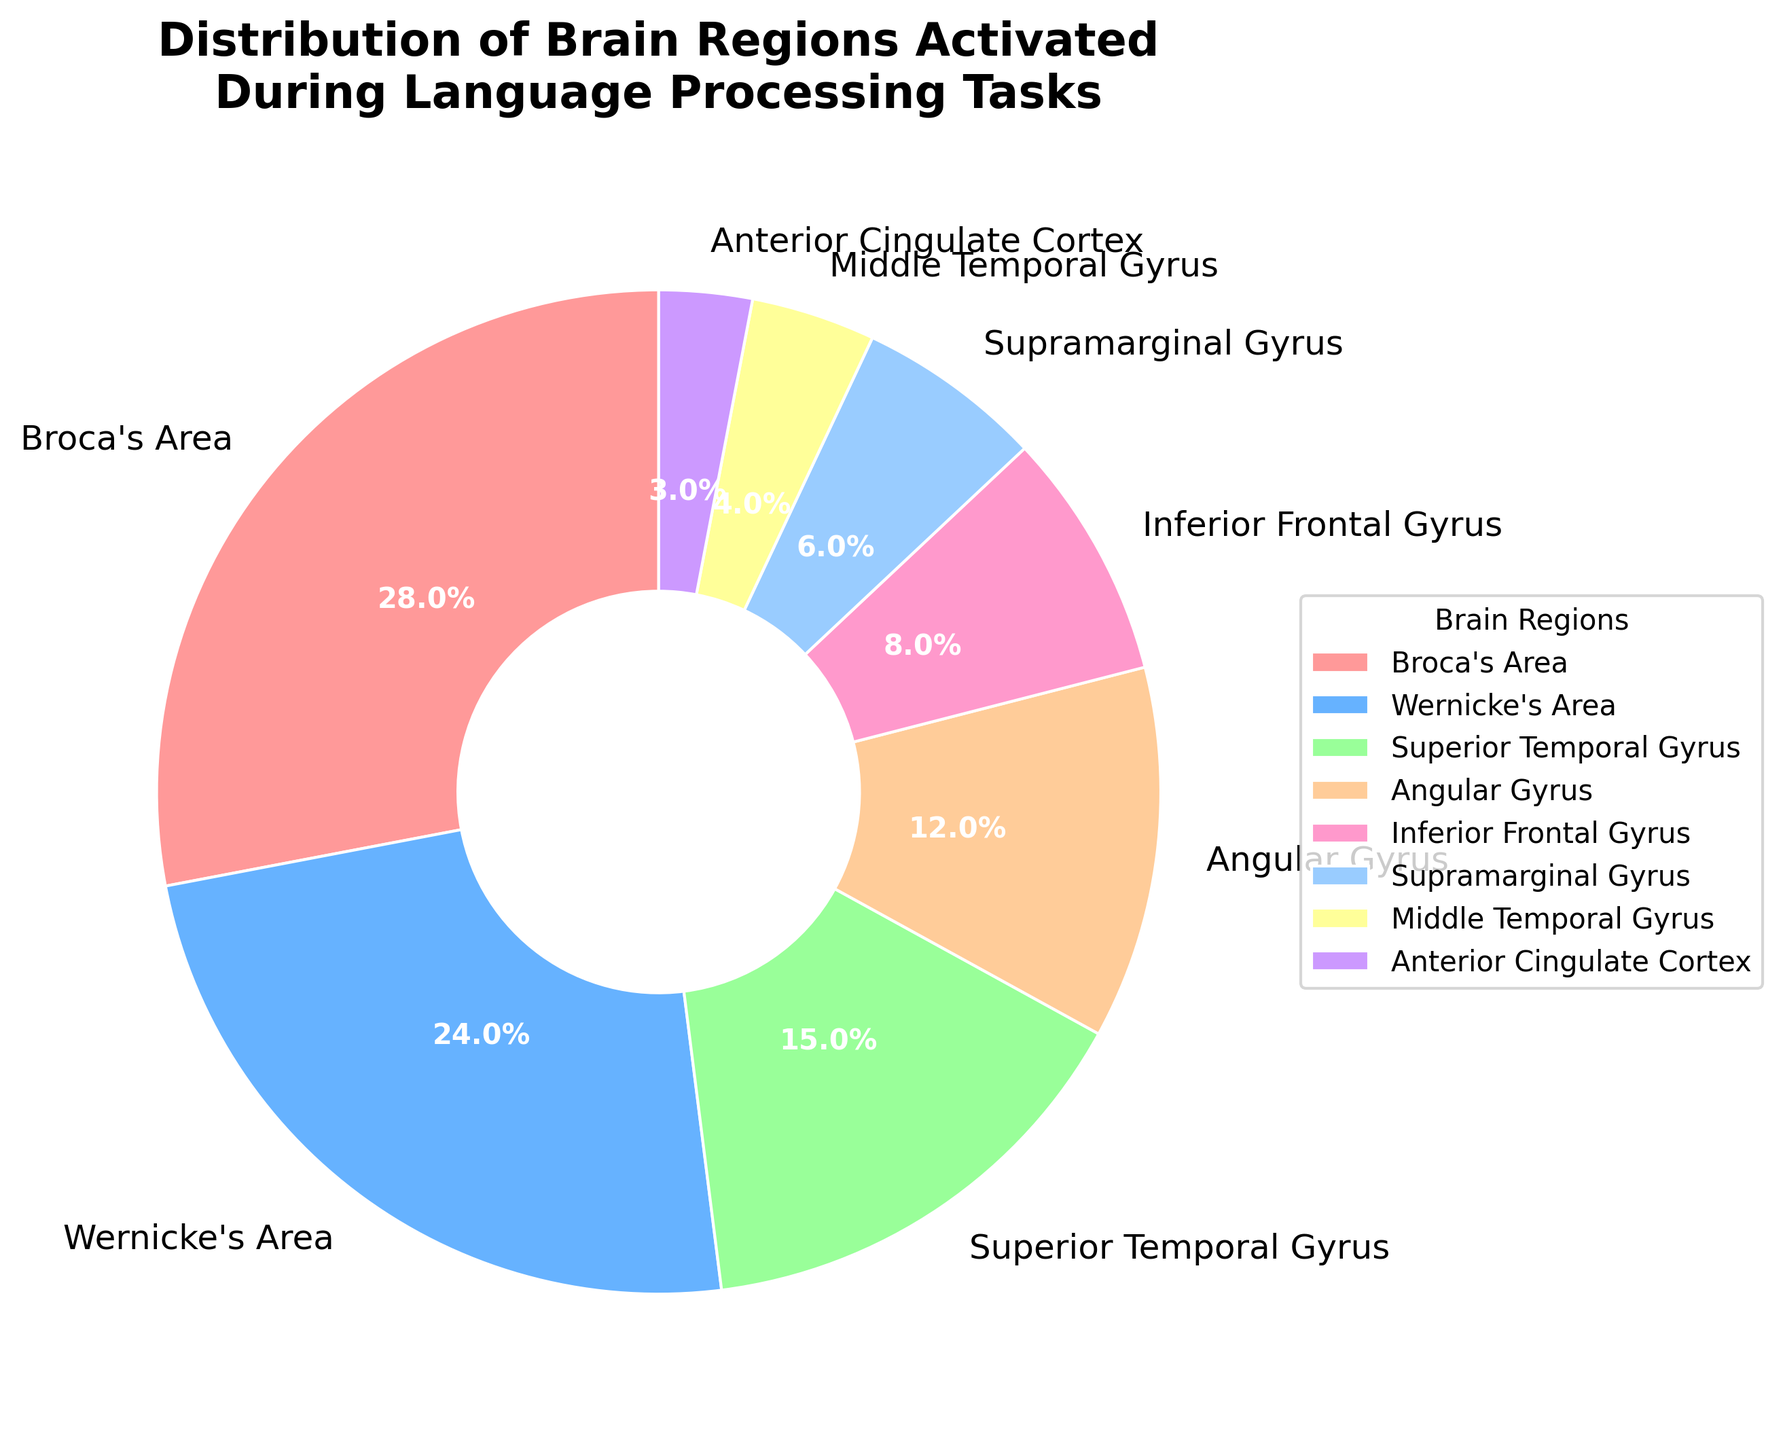What percentage of brain regions is occupied by Broca's Area and Wernicke's Area combined? First, note that Broca's Area occupies 28% and Wernicke's Area occupies 24%. Sum these percentages: 28% + 24% = 52%.
Answer: 52% Which brain region has the highest activation percentage? Identify the brain region with the highest percentage value on the pie chart. Broca's Area has 28%, which is the highest.
Answer: Broca's Area How much more is the activation percentage of Broca's Area compared to Inferior Frontal Gyrus? Broca's Area has 28% while Inferior Frontal Gyrus has 8%. Subtract the smaller percentage from the larger one: 28% - 8% = 20%.
Answer: 20% Which brain regions have an activation percentage greater than 10%? Identify brain regions in the pie chart with activation percentages above 10%. The regions are Broca's Area (28%), Wernicke's Area (24%), Superior Temporal Gyrus (15%), and Angular Gyrus (12%).
Answer: Broca's Area, Wernicke's Area, Superior Temporal Gyrus, Angular Gyrus What is the total activation percentage for brain regions that start with "S"? Identify the regions starting with "S": Superior Temporal Gyrus (15%) and Supramarginal Gyrus (6%). Sum these percentages: 15% + 6% = 21%.
Answer: 21% Which brain region occupies the smallest segment in the pie chart? Locate the smallest segment visually. Anterior Cingulate Cortex has the smallest percentage of 3%.
Answer: Anterior Cingulate Cortex How does the activation percentage of Angular Gyrus compare to that of Superior Temporal Gyrus? Angular Gyrus has 12% and Superior Temporal Gyrus has 15%. Since 12% is less than 15%, Angular Gyrus has a lower activation percentage.
Answer: Less What is the average activation percentage for the brain regions presented? Sum all percentages: 28 + 24 + 15 + 12 + 8 + 6 + 4 + 3 = 100%. There are 8 regions. Average is 100% / 8 = 12.5%.
Answer: 12.5% 